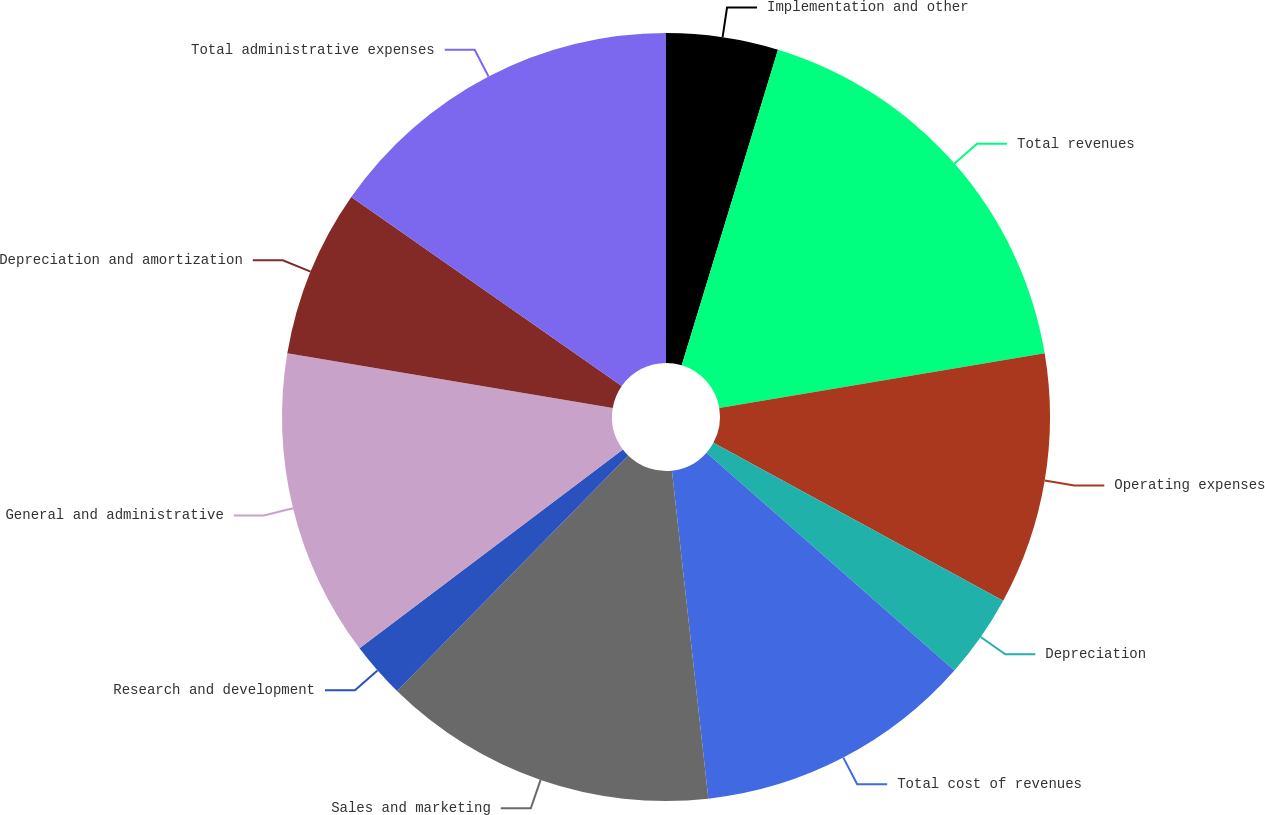<chart> <loc_0><loc_0><loc_500><loc_500><pie_chart><fcel>Implementation and other<fcel>Total revenues<fcel>Operating expenses<fcel>Depreciation<fcel>Total cost of revenues<fcel>Sales and marketing<fcel>Research and development<fcel>General and administrative<fcel>Depreciation and amortization<fcel>Total administrative expenses<nl><fcel>4.71%<fcel>17.64%<fcel>10.59%<fcel>3.54%<fcel>11.76%<fcel>14.11%<fcel>2.36%<fcel>12.94%<fcel>7.06%<fcel>15.29%<nl></chart> 